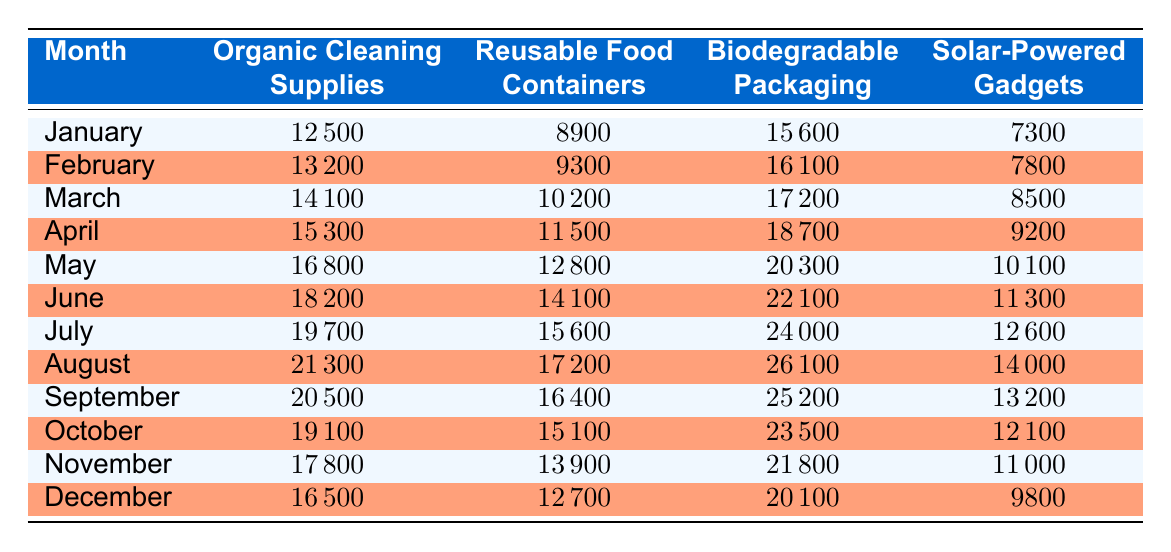What was the revenue for Reusable Food Containers in July? The table shows that in July, the revenue for Reusable Food Containers amounts to 15600.
Answer: 15600 Which month had the highest revenue for Organic Cleaning Supplies? By checking the table, we see that July had the highest revenue of 19700 for Organic Cleaning Supplies.
Answer: July What is the total revenue for Biodegradable Packaging from January to June? To find the total revenue for Biodegradable Packaging from January to June, we add the monthly revenues: 15600 + 16100 + 17200 + 18700 + 20300 + 22100 = 109100.
Answer: 109100 Was the revenue from Solar-Powered Gadgets higher in August than in September? Comparing the two months in the table, August has revenue of 14000, while September has revenue of 13200. Hence, the revenue was higher in August.
Answer: Yes What is the average revenue for Organic Cleaning Supplies over the year? To find the average, first, we sum all the monthly revenues for Organic Cleaning Supplies: 12500 + 13200 + 14100 + 15300 + 16800 + 18200 + 19700 + 21300 + 20500 + 19100 + 17800 + 16500 = 201800. Since there are 12 months, we divide this sum by 12, yielding 201800 / 12 = 16816.67.
Answer: 16816.67 Which product line had the lowest revenue in December? By examining the revenues in December from the table: Organic Cleaning Supplies (16500), Reusable Food Containers (12700), Biodegradable Packaging (20100), and Solar-Powered Gadgets (9800). The lowest is clearly Solar-Powered Gadgets at 9800.
Answer: Solar-Powered Gadgets What was the revenue difference between May and June for Reusable Food Containers? The revenue for Reusable Food Containers in May is 12800 and in June it is 14100. The difference is calculated by subtracting May's revenue from June's: 14100 - 12800 = 1300.
Answer: 1300 Did the revenue for Biodegradable Packaging exceed 20000 every month from May to August? By checking the revenues in those months, we see May: 20300, June: 22100, July: 24000, August: 26100. All four months exceed 20000.
Answer: Yes 